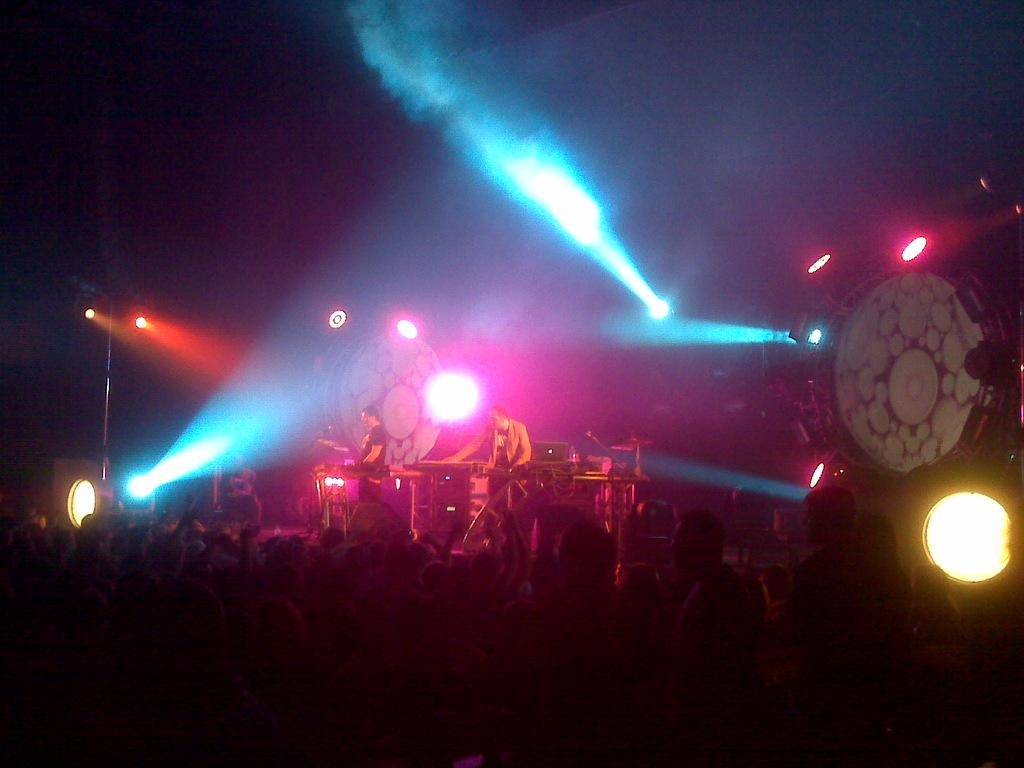How many people are in the image? There is a group of people in the image, but the exact number is not specified. What are the people in the image doing? The presence of musical instruments suggests that the people might be playing music. What can be seen in the image that is related to lighting? Focus lights are visible in the image. What type of percussion instrument is present in the image? Cymbals with cymbal stands are in the image. What is the color of the background in the image? The background of the image is dark. Can you tell me how many cacti are in the image? There are no cacti present in the image. What angle is the stream visible from in the image? There is no stream visible in the image. 